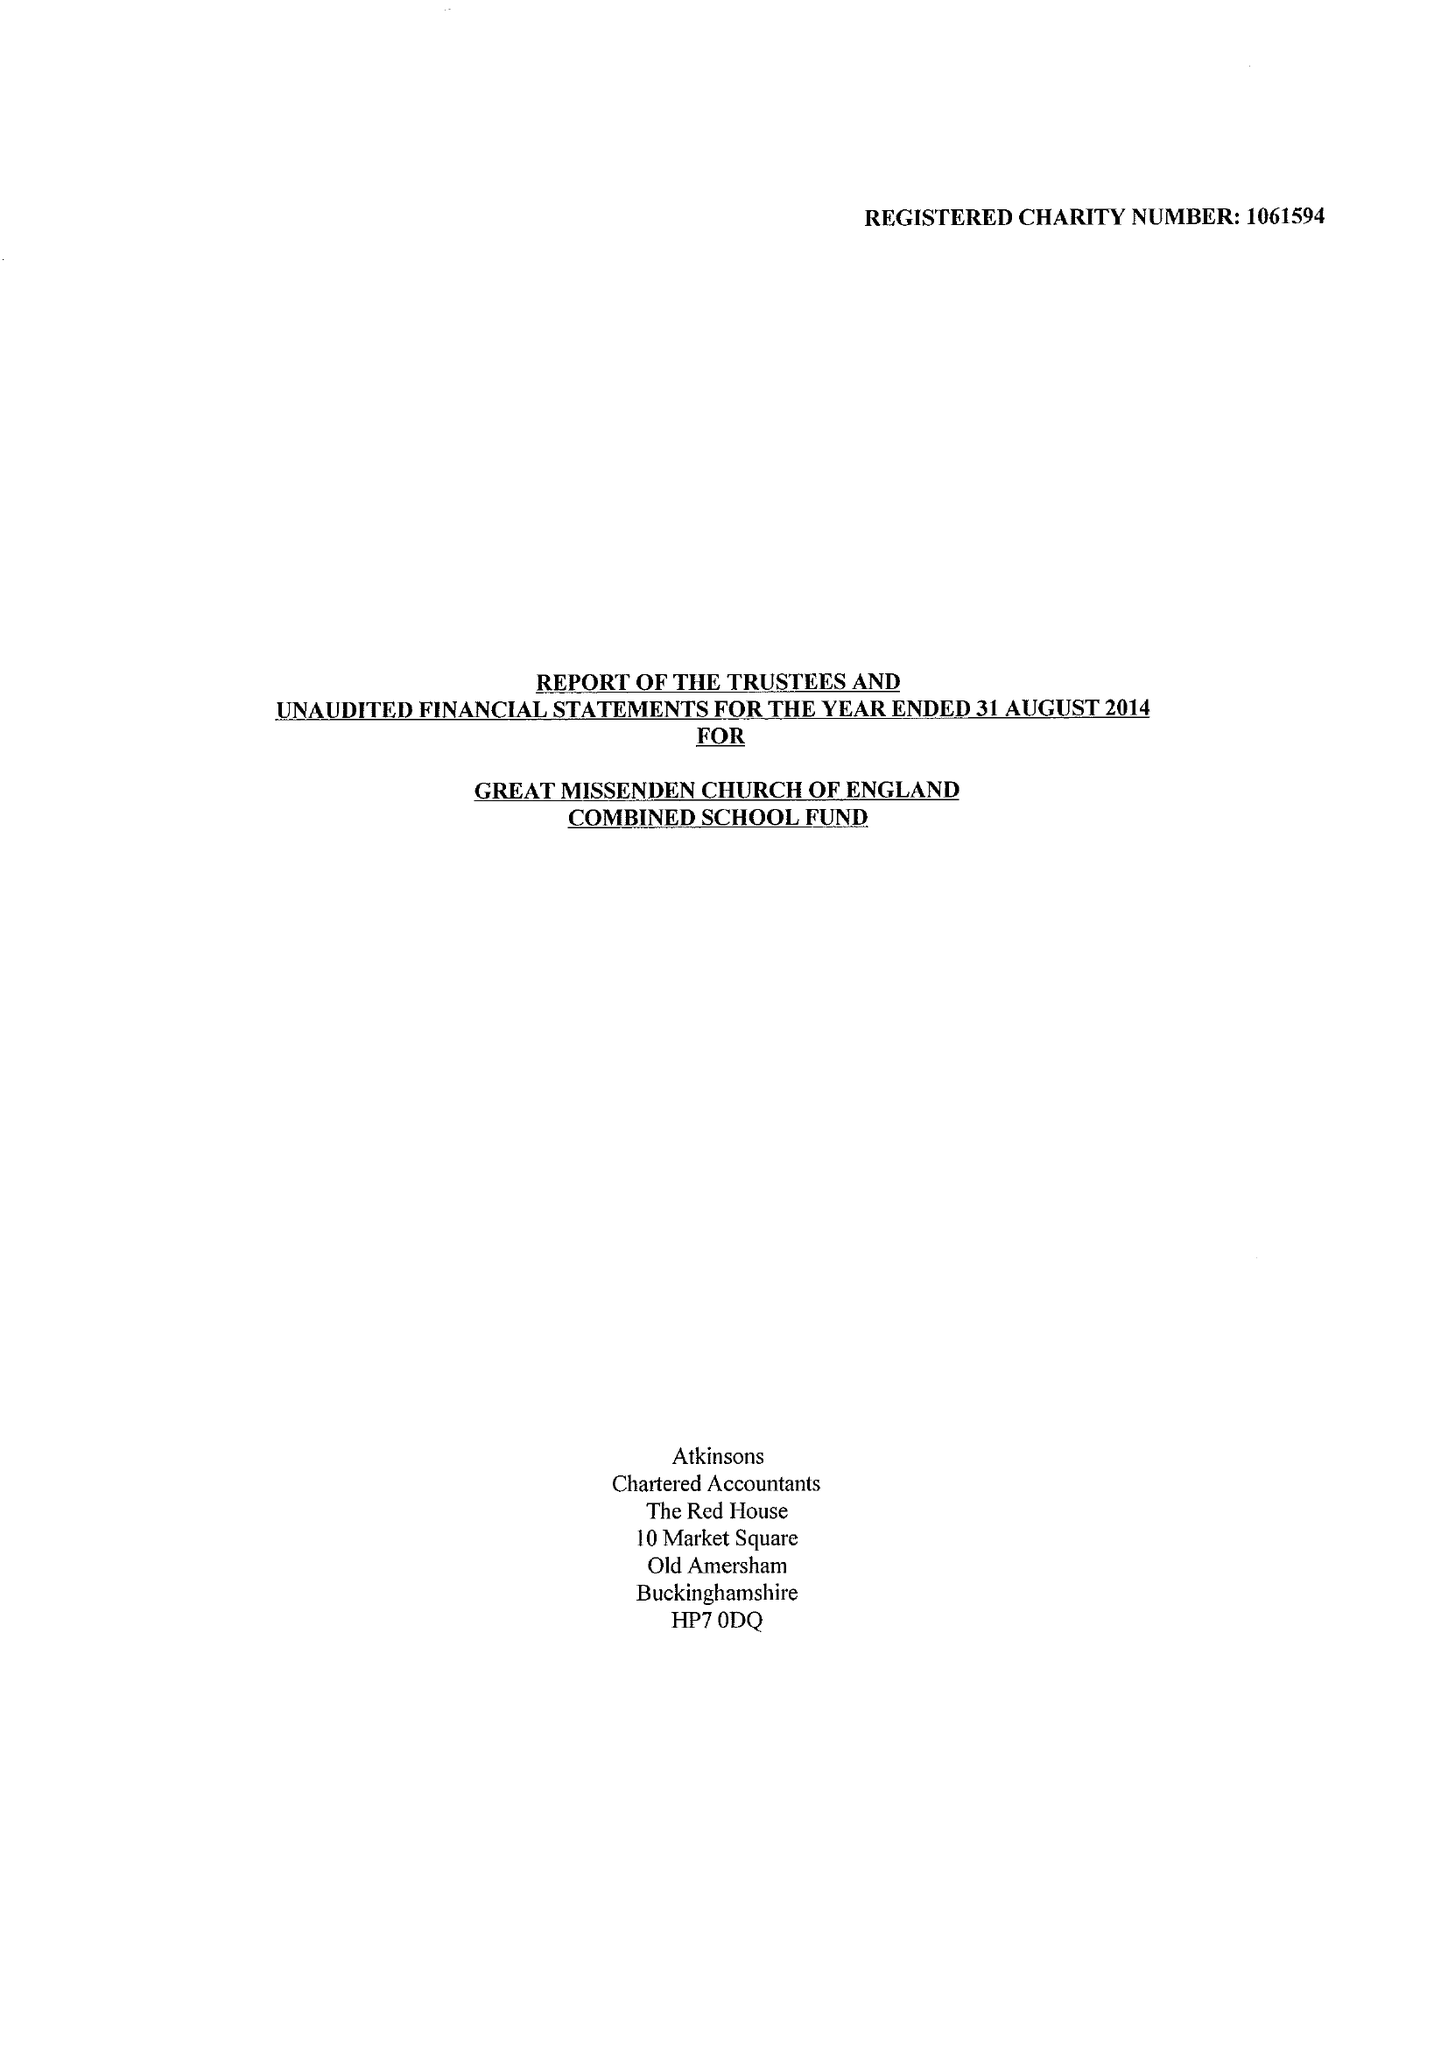What is the value for the charity_name?
Answer the question using a single word or phrase. Great Missenden C Of E Combined School Fund 